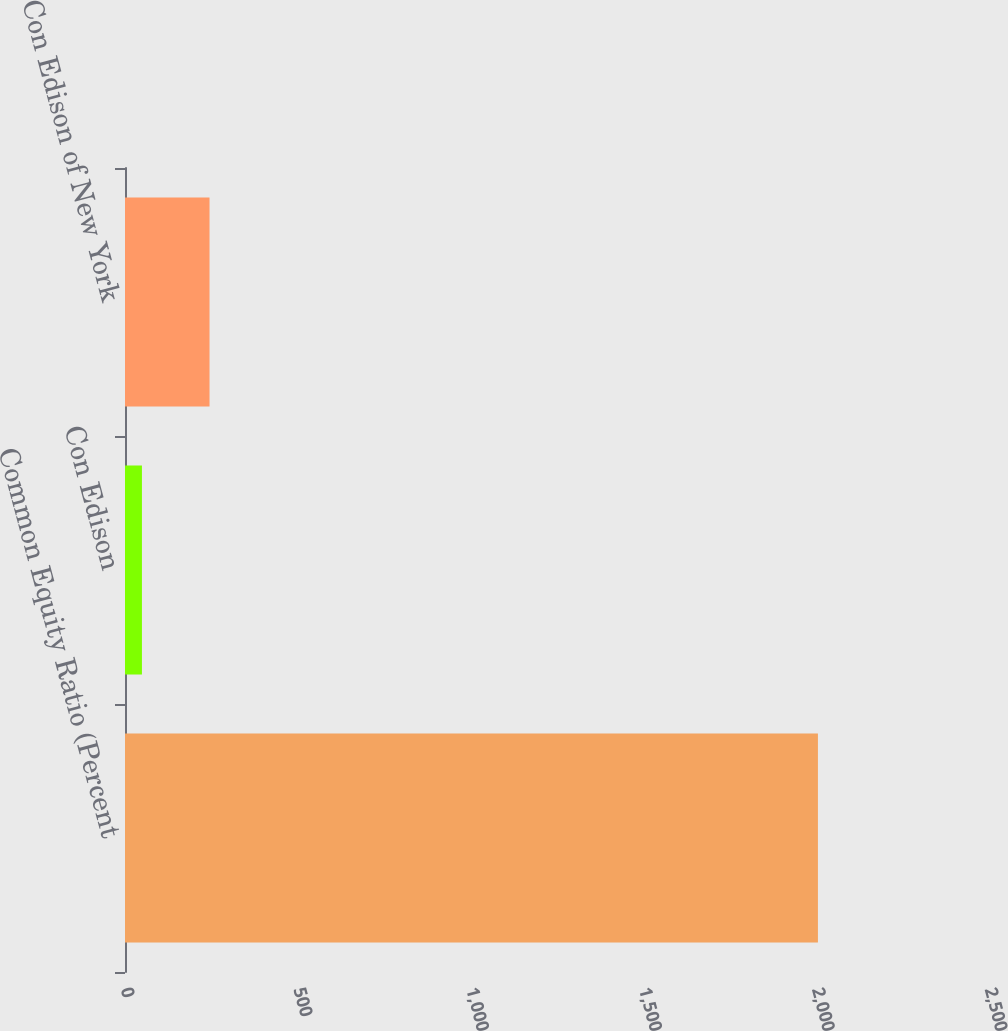Convert chart. <chart><loc_0><loc_0><loc_500><loc_500><bar_chart><fcel>Common Equity Ratio (Percent<fcel>Con Edison<fcel>Con Edison of New York<nl><fcel>2005<fcel>49<fcel>244.6<nl></chart> 